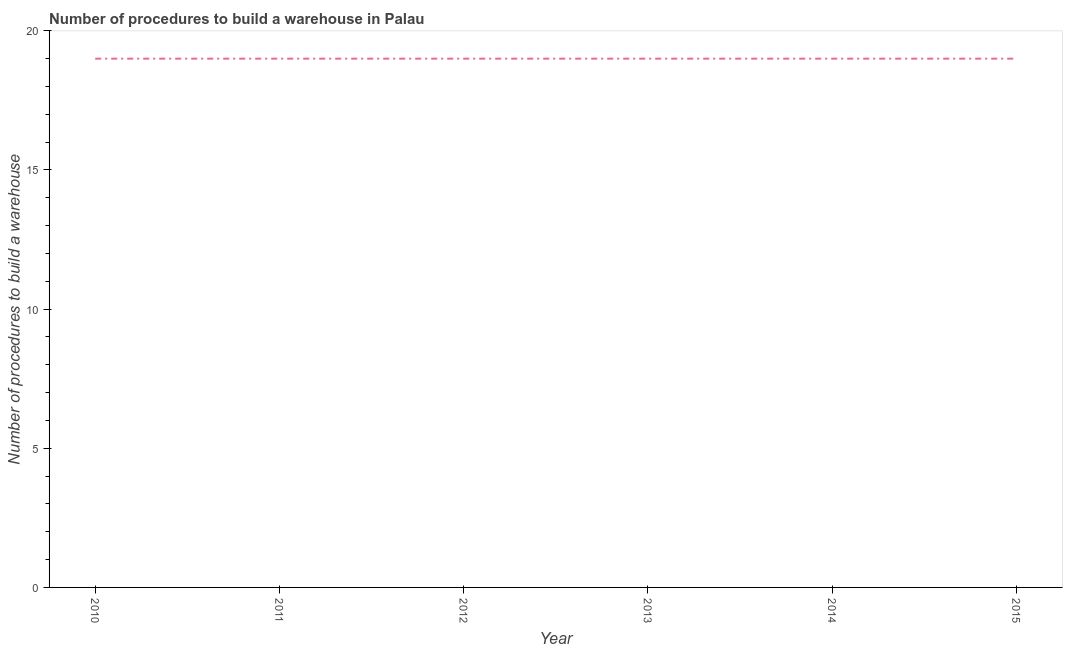What is the number of procedures to build a warehouse in 2010?
Offer a terse response. 19. Across all years, what is the maximum number of procedures to build a warehouse?
Provide a succinct answer. 19. Across all years, what is the minimum number of procedures to build a warehouse?
Make the answer very short. 19. In which year was the number of procedures to build a warehouse maximum?
Keep it short and to the point. 2010. What is the sum of the number of procedures to build a warehouse?
Provide a short and direct response. 114. What is the average number of procedures to build a warehouse per year?
Ensure brevity in your answer.  19. What is the median number of procedures to build a warehouse?
Your response must be concise. 19. Is the difference between the number of procedures to build a warehouse in 2010 and 2013 greater than the difference between any two years?
Offer a very short reply. Yes. What is the difference between the highest and the second highest number of procedures to build a warehouse?
Your response must be concise. 0. Is the sum of the number of procedures to build a warehouse in 2010 and 2012 greater than the maximum number of procedures to build a warehouse across all years?
Your answer should be compact. Yes. In how many years, is the number of procedures to build a warehouse greater than the average number of procedures to build a warehouse taken over all years?
Offer a very short reply. 0. Does the number of procedures to build a warehouse monotonically increase over the years?
Offer a terse response. No. How many lines are there?
Provide a succinct answer. 1. How many years are there in the graph?
Offer a terse response. 6. What is the difference between two consecutive major ticks on the Y-axis?
Provide a short and direct response. 5. Are the values on the major ticks of Y-axis written in scientific E-notation?
Offer a terse response. No. Does the graph contain grids?
Offer a terse response. No. What is the title of the graph?
Your response must be concise. Number of procedures to build a warehouse in Palau. What is the label or title of the X-axis?
Provide a short and direct response. Year. What is the label or title of the Y-axis?
Provide a succinct answer. Number of procedures to build a warehouse. What is the Number of procedures to build a warehouse in 2010?
Make the answer very short. 19. What is the Number of procedures to build a warehouse of 2011?
Keep it short and to the point. 19. What is the Number of procedures to build a warehouse of 2012?
Keep it short and to the point. 19. What is the Number of procedures to build a warehouse of 2015?
Ensure brevity in your answer.  19. What is the difference between the Number of procedures to build a warehouse in 2010 and 2011?
Offer a terse response. 0. What is the difference between the Number of procedures to build a warehouse in 2010 and 2013?
Keep it short and to the point. 0. What is the difference between the Number of procedures to build a warehouse in 2011 and 2015?
Ensure brevity in your answer.  0. What is the difference between the Number of procedures to build a warehouse in 2014 and 2015?
Ensure brevity in your answer.  0. What is the ratio of the Number of procedures to build a warehouse in 2010 to that in 2012?
Make the answer very short. 1. What is the ratio of the Number of procedures to build a warehouse in 2010 to that in 2015?
Offer a very short reply. 1. What is the ratio of the Number of procedures to build a warehouse in 2011 to that in 2012?
Offer a very short reply. 1. What is the ratio of the Number of procedures to build a warehouse in 2011 to that in 2014?
Give a very brief answer. 1. What is the ratio of the Number of procedures to build a warehouse in 2013 to that in 2014?
Offer a very short reply. 1. 